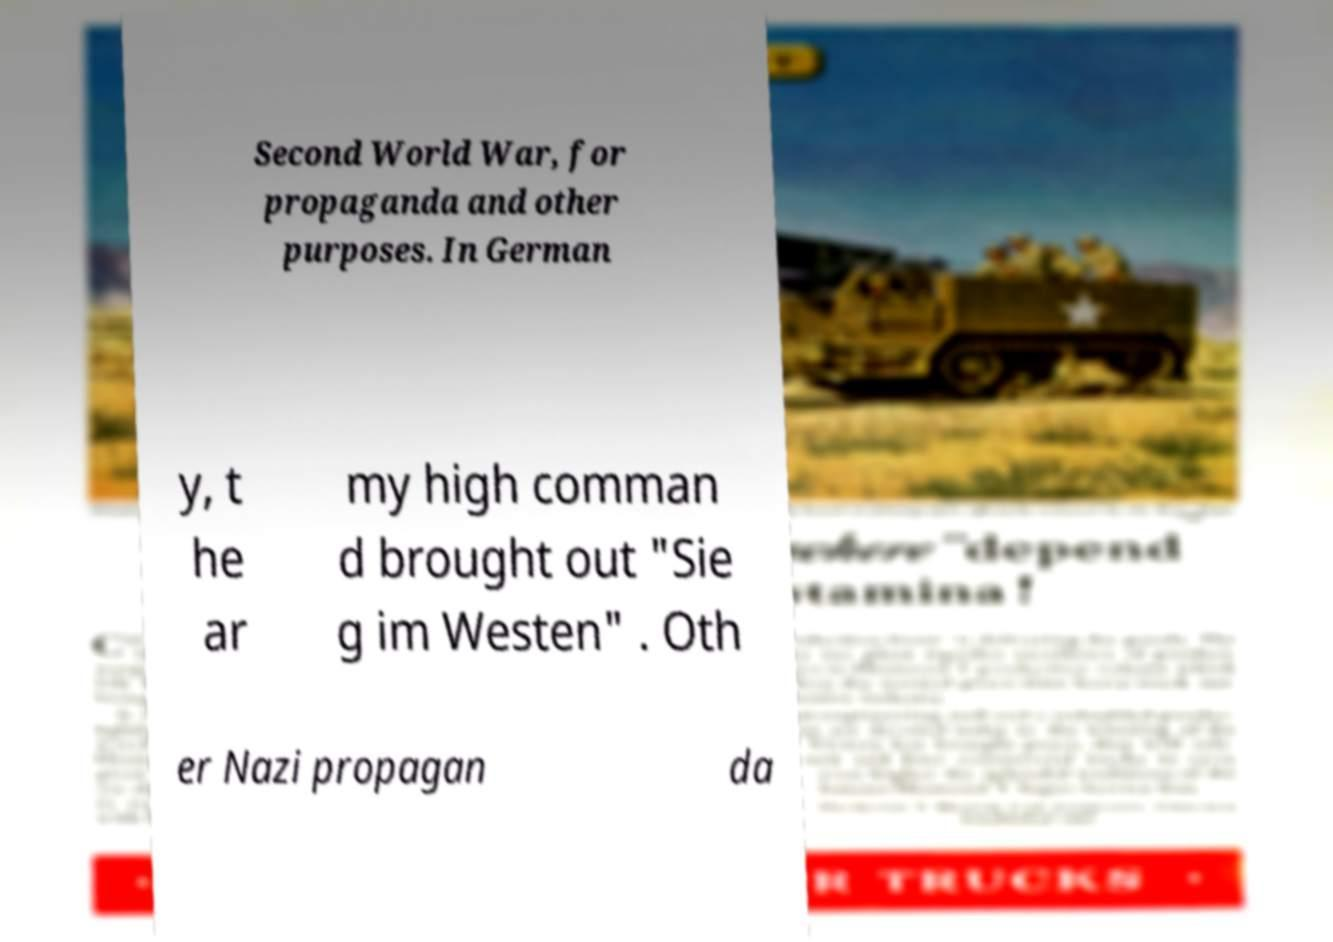Can you read and provide the text displayed in the image?This photo seems to have some interesting text. Can you extract and type it out for me? Second World War, for propaganda and other purposes. In German y, t he ar my high comman d brought out "Sie g im Westen" . Oth er Nazi propagan da 